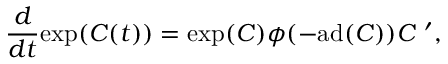<formula> <loc_0><loc_0><loc_500><loc_500>{ \frac { d } { d t } } e x p ( C ( t ) ) = e x p ( C ) \phi ( - a d ( C ) ) C ^ { \prime } ,</formula> 